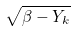<formula> <loc_0><loc_0><loc_500><loc_500>\sqrt { { \beta - { Y } _ { k } } }</formula> 